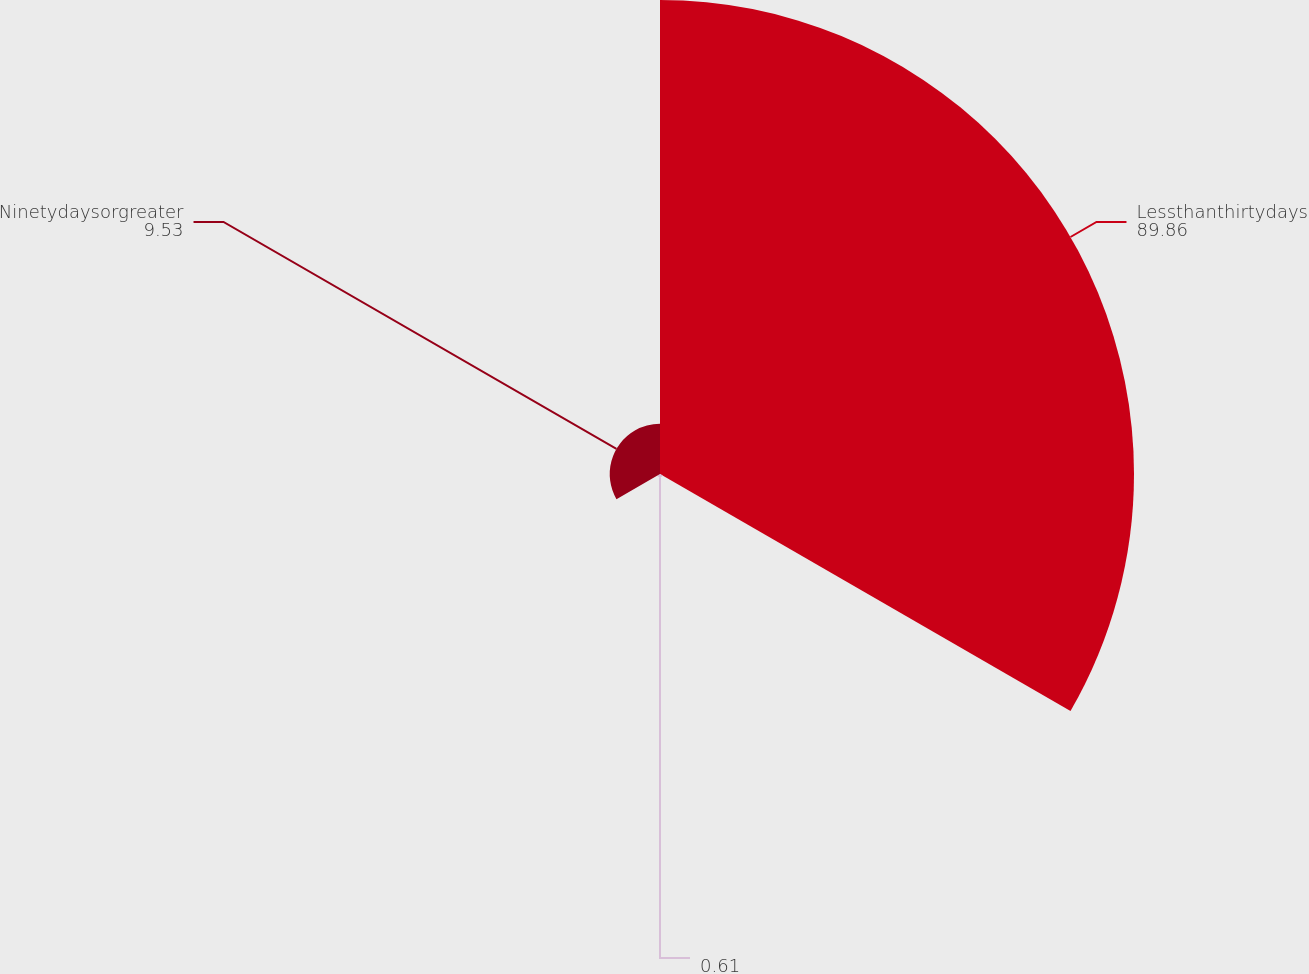<chart> <loc_0><loc_0><loc_500><loc_500><pie_chart><fcel>Lessthanthirtydays<fcel>Unnamed: 1<fcel>Ninetydaysorgreater<nl><fcel>89.86%<fcel>0.61%<fcel>9.53%<nl></chart> 